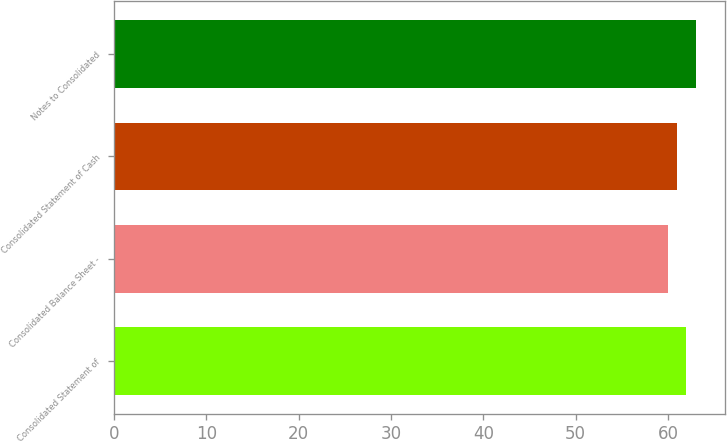<chart> <loc_0><loc_0><loc_500><loc_500><bar_chart><fcel>Consolidated Statement of<fcel>Consolidated Balance Sheet -<fcel>Consolidated Statement of Cash<fcel>Notes to Consolidated<nl><fcel>62<fcel>60<fcel>61<fcel>63<nl></chart> 